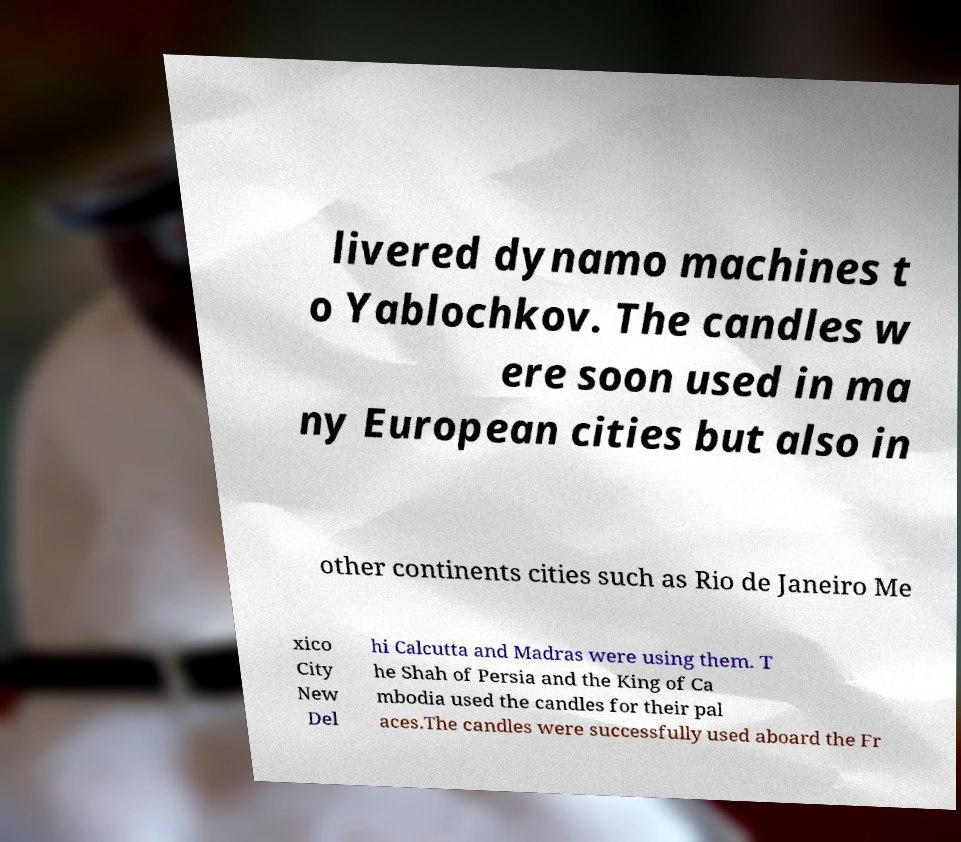There's text embedded in this image that I need extracted. Can you transcribe it verbatim? livered dynamo machines t o Yablochkov. The candles w ere soon used in ma ny European cities but also in other continents cities such as Rio de Janeiro Me xico City New Del hi Calcutta and Madras were using them. T he Shah of Persia and the King of Ca mbodia used the candles for their pal aces.The candles were successfully used aboard the Fr 